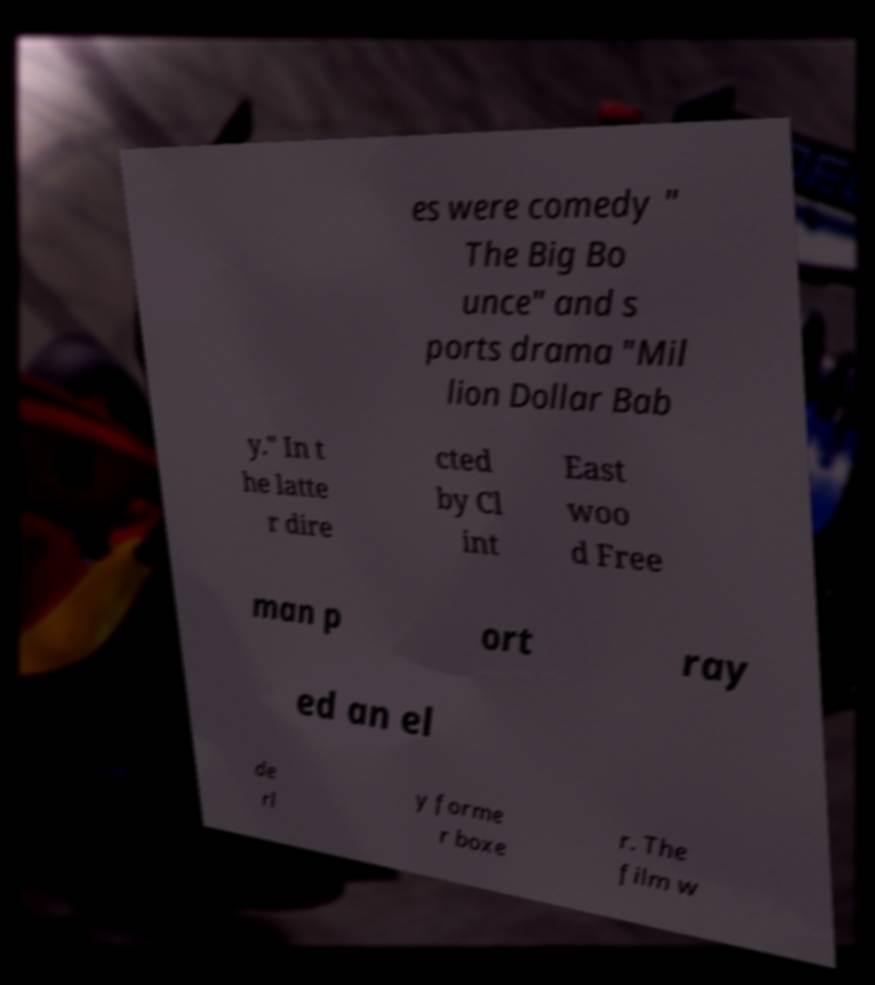Please identify and transcribe the text found in this image. es were comedy " The Big Bo unce" and s ports drama "Mil lion Dollar Bab y." In t he latte r dire cted by Cl int East woo d Free man p ort ray ed an el de rl y forme r boxe r. The film w 